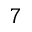<formula> <loc_0><loc_0><loc_500><loc_500>7</formula> 